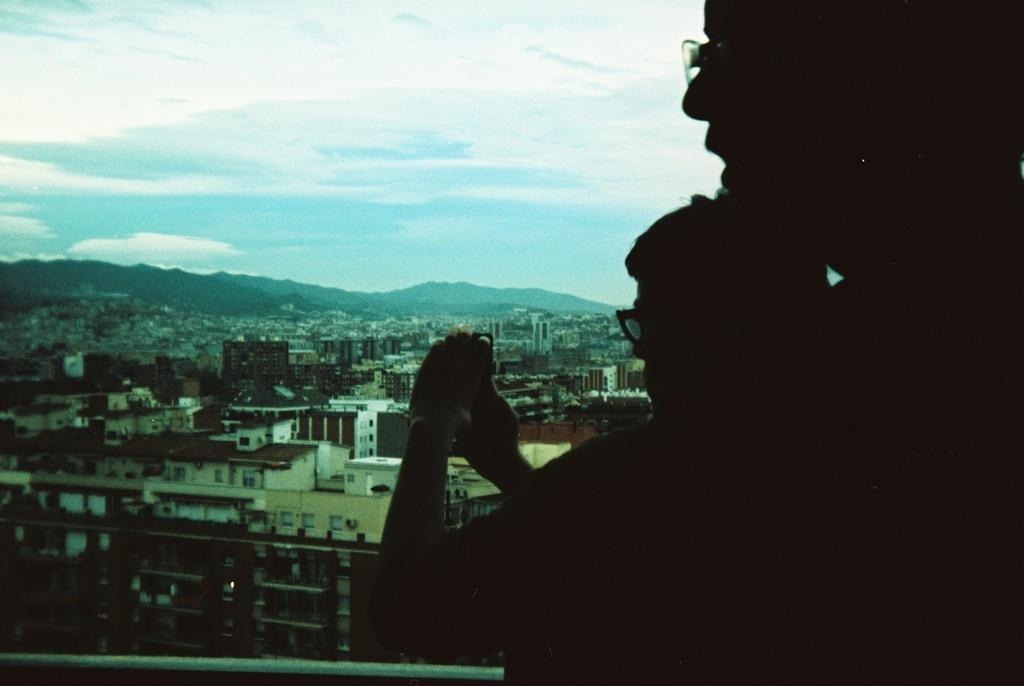How many people are in the image? There are two persons in the image. What is one of the persons doing? One of the persons is holding a camera. What type of structures can be seen in the image? There are buildings visible in the image. What type of vegetation can be seen in the image? There are trees visible in the image. What type of fruit is the person holding in the image? There is no fruit visible in the image; one of the persons is holding a camera. Can you see a donkey in the image? There is no donkey present in the image. 